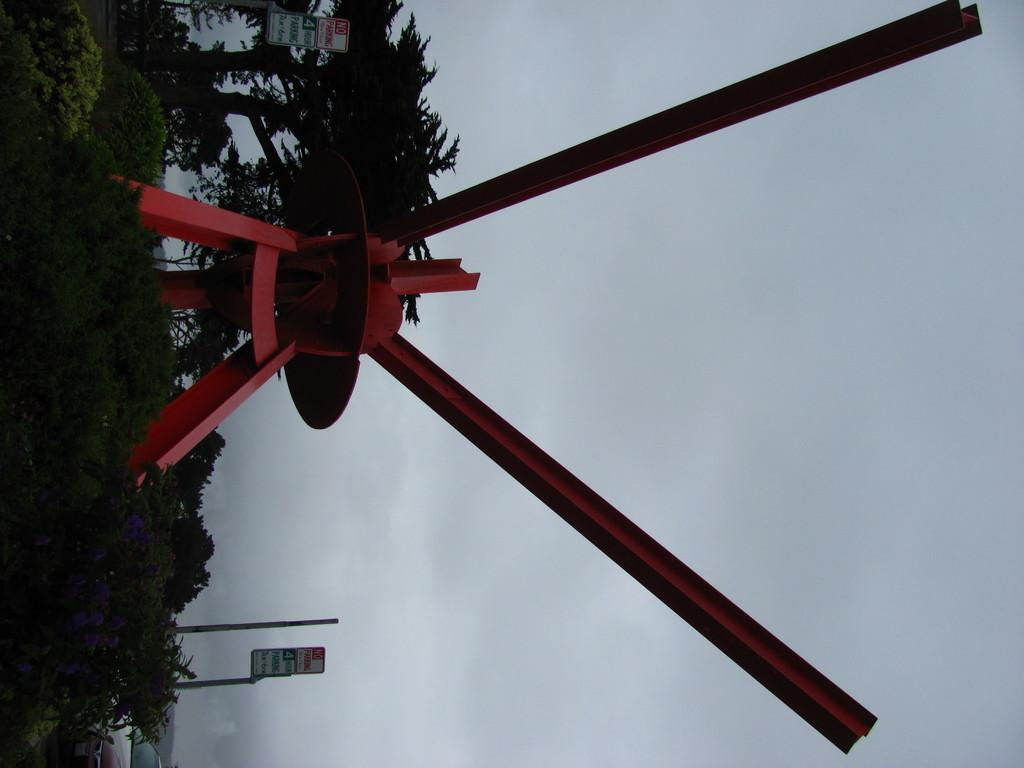What is the main subject in the center of the image? There is a turbine in the center of the image. What can be seen in the background of the image? There are trees in the background of the image. What type of informational signs are visible in the image? There are sign boards and name boards visible in the image. What type of gold border can be seen around the turbine in the image? There is no gold border around the turbine in the image; the turbine is the main focus without any additional decorative elements. 